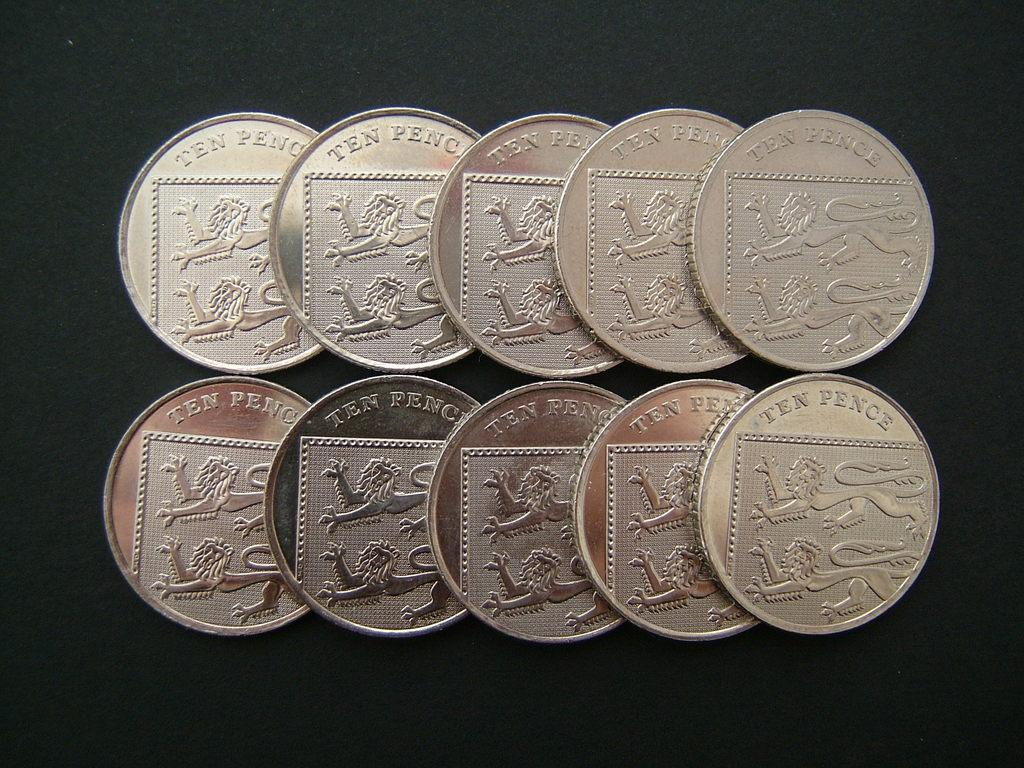<image>
Share a concise interpretation of the image provided. Ten golden colored coins that say Ten Pence. 